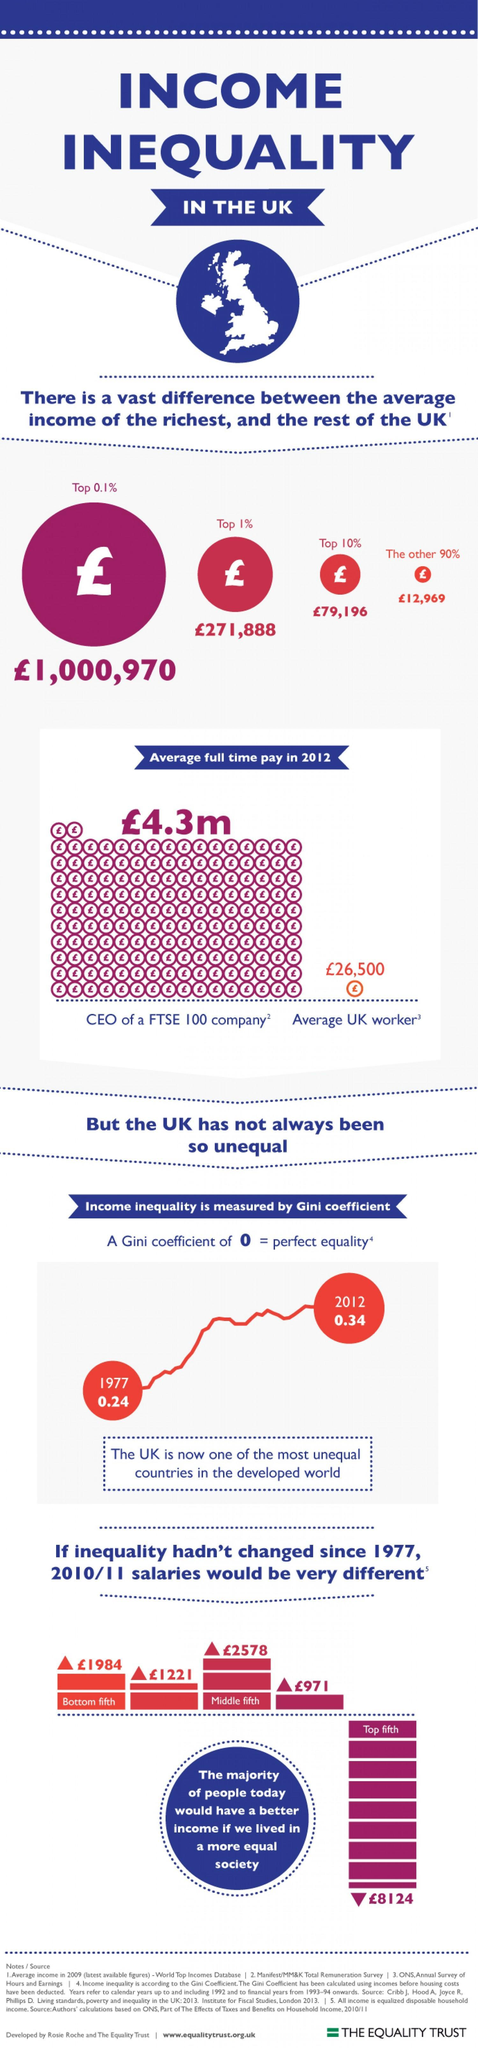What is the average income in pounds for the top 10%
Answer the question with a short phrase. 79,196 What is the full time pay in pounds of an average UK worker 26,500 By how many points did the Gini coefficient rise from 1977  to 2012 0.14 